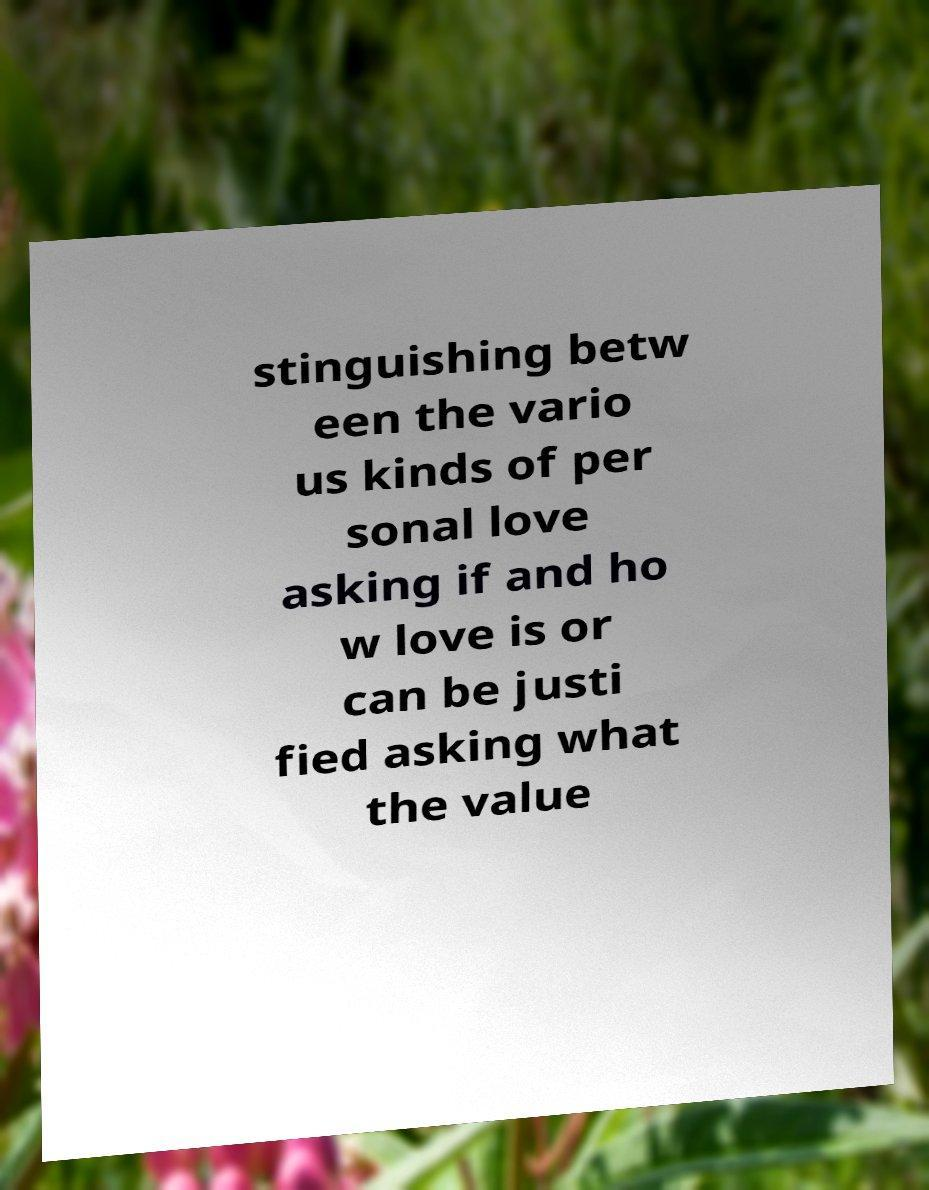There's text embedded in this image that I need extracted. Can you transcribe it verbatim? stinguishing betw een the vario us kinds of per sonal love asking if and ho w love is or can be justi fied asking what the value 